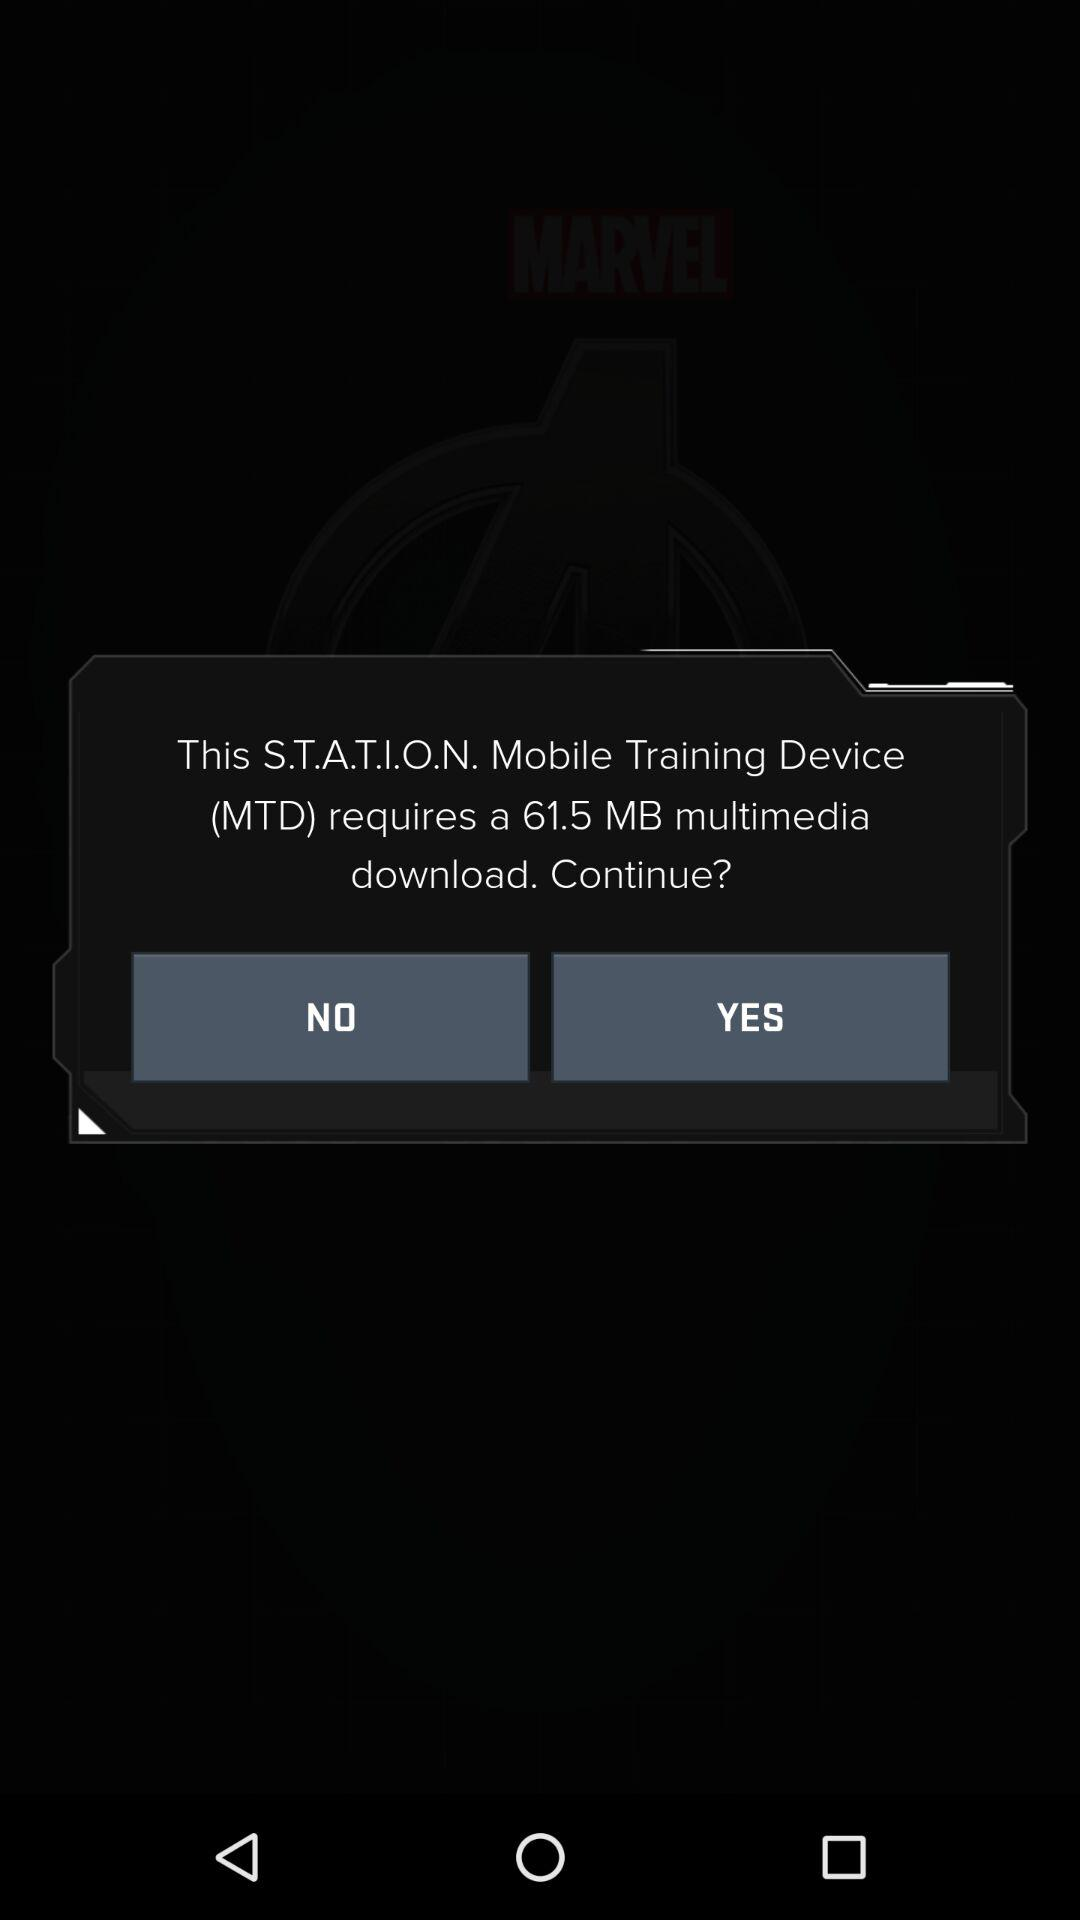How many MB is the download?
Answer the question using a single word or phrase. 61.5 